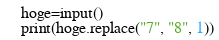<code> <loc_0><loc_0><loc_500><loc_500><_Python_>hoge=input()
print(hoge.replace("7", "8", 1))</code> 